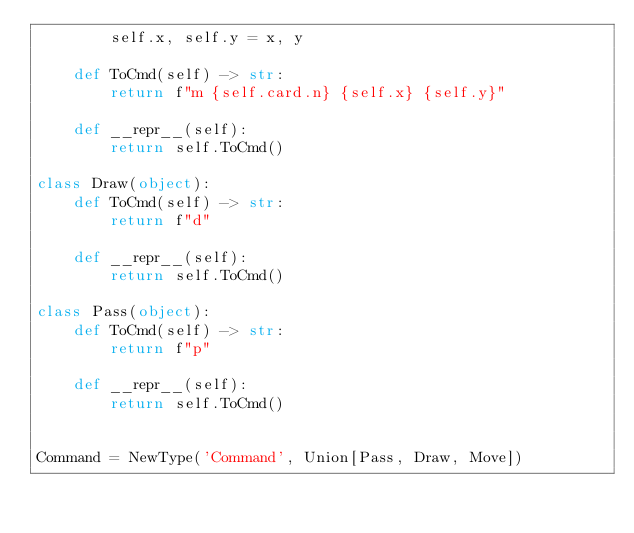<code> <loc_0><loc_0><loc_500><loc_500><_Python_>        self.x, self.y = x, y

    def ToCmd(self) -> str:
        return f"m {self.card.n} {self.x} {self.y}"

    def __repr__(self):
        return self.ToCmd()

class Draw(object):
    def ToCmd(self) -> str:
        return f"d"
    
    def __repr__(self):
        return self.ToCmd()

class Pass(object):
    def ToCmd(self) -> str:
        return f"p"
    
    def __repr__(self):
        return self.ToCmd()


Command = NewType('Command', Union[Pass, Draw, Move])
</code> 